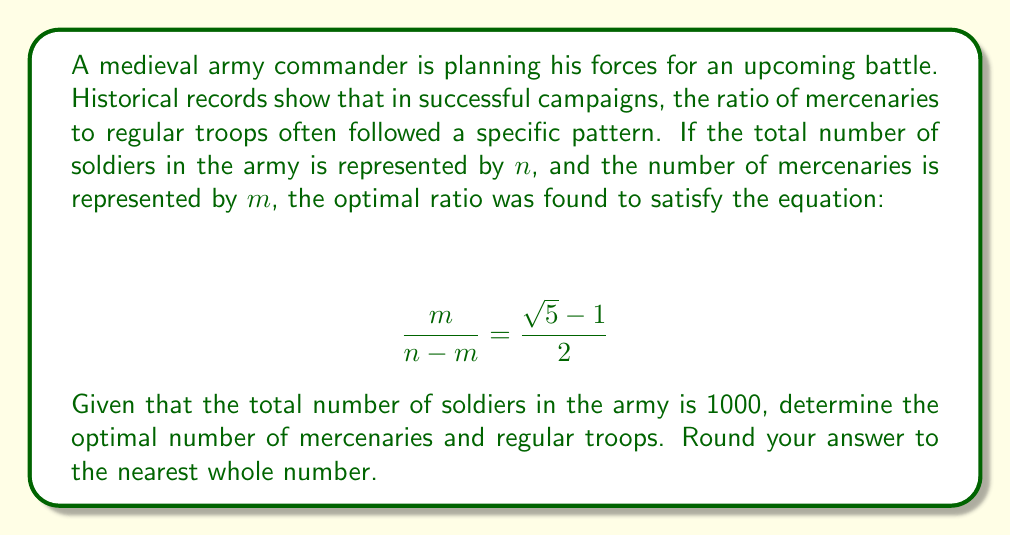Help me with this question. To solve this problem, we'll follow these steps:

1) First, let's recognize the right side of the equation. The fraction $\frac{\sqrt{5}-1}{2}$ is actually the golden ratio, often denoted by $\phi$. So we can rewrite our equation as:

   $$ \frac{m}{n-m} = \phi $$

2) We're given that the total number of soldiers $n = 1000$. Let's substitute this:

   $$ \frac{m}{1000-m} = \phi $$

3) Now, let's solve for $m$:
   
   $m = 1000\phi - m\phi$
   $m + m\phi = 1000\phi$
   $m(1 + \phi) = 1000\phi$
   $m = \frac{1000\phi}{1 + \phi}$

4) We know that $\phi = \frac{\sqrt{5}-1}{2} \approx 0.618034$. Let's substitute this:

   $m = \frac{1000 \cdot 0.618034}{1 + 0.618034} = \frac{618.034}{1.618034} \approx 382.0$

5) Rounding to the nearest whole number, we get 382 mercenaries.

6) The number of regular troops would be $1000 - 382 = 618$.

This ratio of mercenaries to regular troops (382:618) is very close to the golden ratio (0.618:1), which aligns with the historical pattern described in the question.
Answer: The optimal number of mercenaries is 382, and the optimal number of regular troops is 618. 